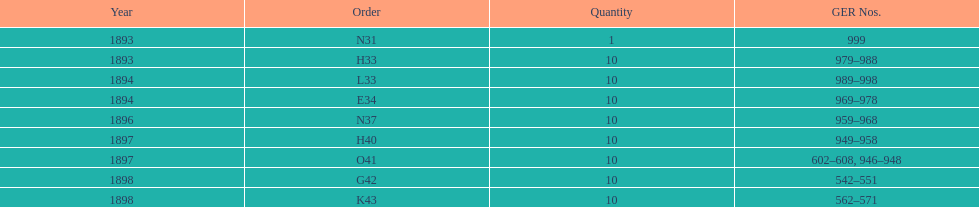Was the volume larger in 1894 or 1893? 1894. Give me the full table as a dictionary. {'header': ['Year', 'Order', 'Quantity', 'GER Nos.'], 'rows': [['1893', 'N31', '1', '999'], ['1893', 'H33', '10', '979–988'], ['1894', 'L33', '10', '989–998'], ['1894', 'E34', '10', '969–978'], ['1896', 'N37', '10', '959–968'], ['1897', 'H40', '10', '949–958'], ['1897', 'O41', '10', '602–608, 946–948'], ['1898', 'G42', '10', '542–551'], ['1898', 'K43', '10', '562–571']]} 